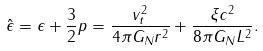<formula> <loc_0><loc_0><loc_500><loc_500>\hat { \epsilon } = \epsilon + \frac { 3 } { 2 } p = \frac { v _ { t } ^ { 2 } } { 4 \pi G _ { N } r ^ { 2 } } + \frac { \xi c ^ { 2 } } { 8 \pi G _ { N } L ^ { 2 } } .</formula> 